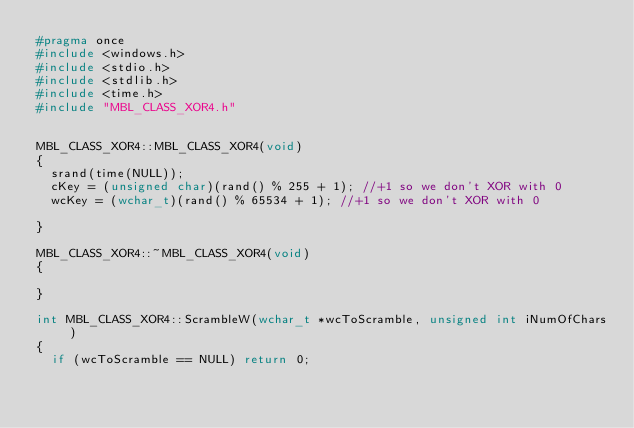Convert code to text. <code><loc_0><loc_0><loc_500><loc_500><_C++_>#pragma once
#include <windows.h>
#include <stdio.h>
#include <stdlib.h>
#include <time.h>
#include "MBL_CLASS_XOR4.h"


MBL_CLASS_XOR4::MBL_CLASS_XOR4(void)
{
	srand(time(NULL));
	cKey = (unsigned char)(rand() % 255 + 1); //+1 so we don't XOR with 0
	wcKey = (wchar_t)(rand() % 65534 + 1); //+1 so we don't XOR with 0

}

MBL_CLASS_XOR4::~MBL_CLASS_XOR4(void)
{

}

int MBL_CLASS_XOR4::ScrambleW(wchar_t *wcToScramble, unsigned int iNumOfChars)
{
	if (wcToScramble == NULL) return 0;</code> 